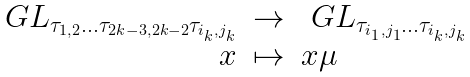Convert formula to latex. <formula><loc_0><loc_0><loc_500><loc_500>\begin{array} { r c l } \ G L _ { \tau _ { 1 , 2 } \dots \tau _ { 2 k - 3 , 2 k - 2 } \tau _ { i _ { k } , j _ { k } } } & \to & \ G L _ { \tau _ { i _ { 1 } , j _ { 1 } } \dots \tau _ { i _ { k } , j _ { k } } } \\ x & \mapsto & x \mu \end{array}</formula> 